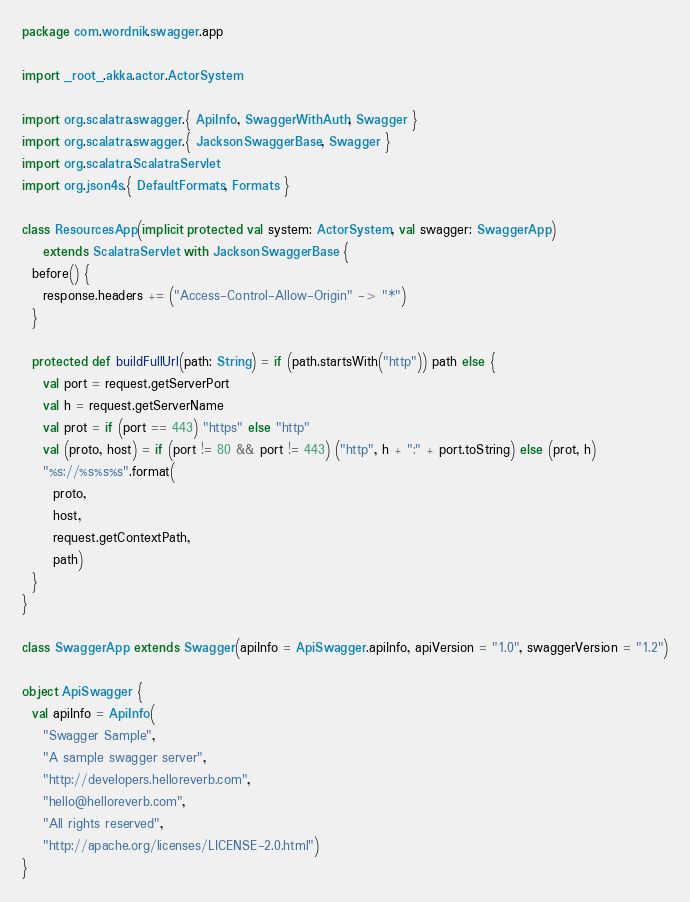Convert code to text. <code><loc_0><loc_0><loc_500><loc_500><_Scala_>package com.wordnik.swagger.app

import _root_.akka.actor.ActorSystem

import org.scalatra.swagger.{ ApiInfo, SwaggerWithAuth, Swagger }
import org.scalatra.swagger.{ JacksonSwaggerBase, Swagger }
import org.scalatra.ScalatraServlet
import org.json4s.{ DefaultFormats, Formats }

class ResourcesApp(implicit protected val system: ActorSystem, val swagger: SwaggerApp)
    extends ScalatraServlet with JacksonSwaggerBase {
  before() {
    response.headers += ("Access-Control-Allow-Origin" -> "*")
  }

  protected def buildFullUrl(path: String) = if (path.startsWith("http")) path else {
    val port = request.getServerPort
    val h = request.getServerName
    val prot = if (port == 443) "https" else "http"
    val (proto, host) = if (port != 80 && port != 443) ("http", h + ":" + port.toString) else (prot, h)
    "%s://%s%s%s".format(
      proto,
      host,
      request.getContextPath,
      path)
  }
}

class SwaggerApp extends Swagger(apiInfo = ApiSwagger.apiInfo, apiVersion = "1.0", swaggerVersion = "1.2")

object ApiSwagger {
  val apiInfo = ApiInfo(
    "Swagger Sample",
    "A sample swagger server",
    "http://developers.helloreverb.com",
    "hello@helloreverb.com",
    "All rights reserved",
    "http://apache.org/licenses/LICENSE-2.0.html")
}
</code> 